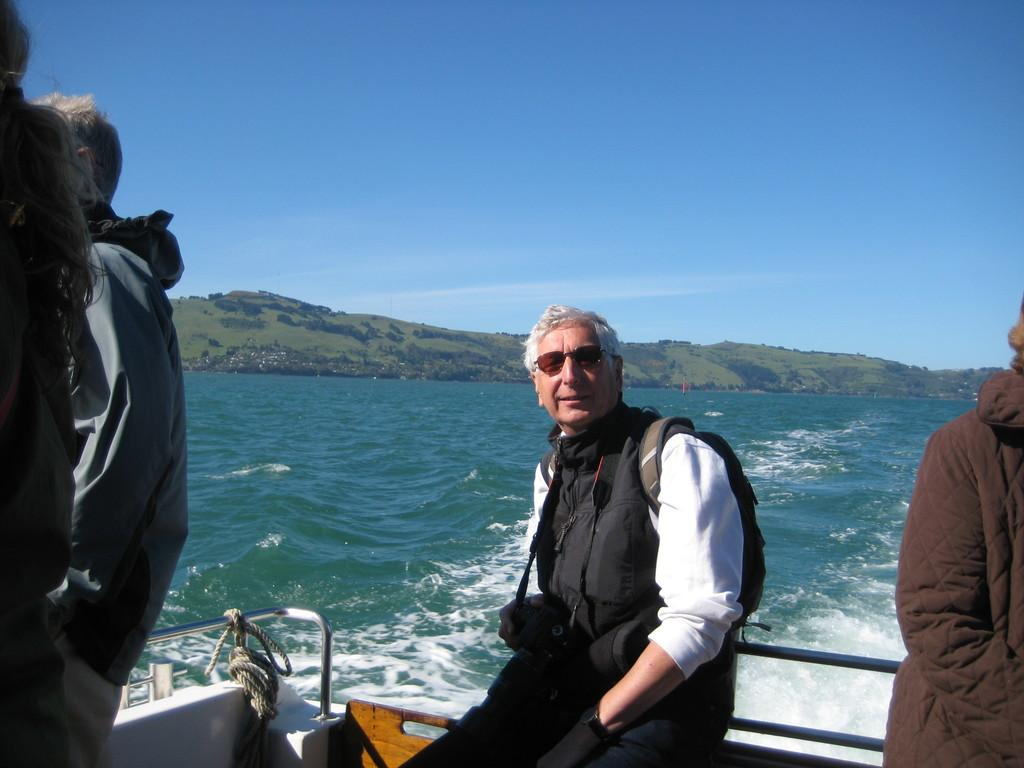What are the people in the image doing? The people in the image are on a boat. Where is the boat located? The boat is on the water. What can be seen in the distance in the image? There are hills visible in the image. What is visible in the background of the image? The sky is visible in the background of the image. What type of pets are being fed on the boat in the image? There are no pets visible in the image, so it is not possible to determine if any pets are being fed. 